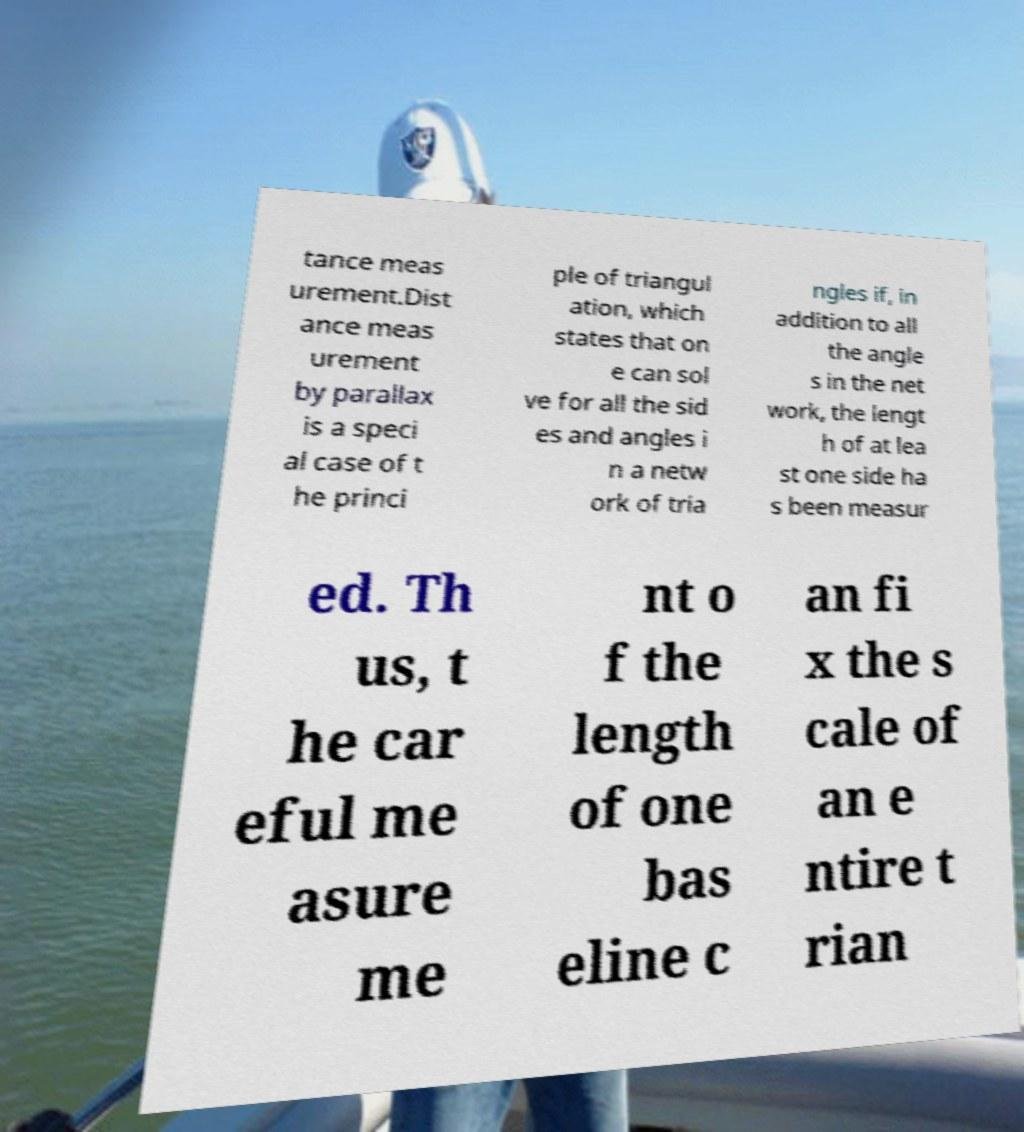For documentation purposes, I need the text within this image transcribed. Could you provide that? tance meas urement.Dist ance meas urement by parallax is a speci al case of t he princi ple of triangul ation, which states that on e can sol ve for all the sid es and angles i n a netw ork of tria ngles if, in addition to all the angle s in the net work, the lengt h of at lea st one side ha s been measur ed. Th us, t he car eful me asure me nt o f the length of one bas eline c an fi x the s cale of an e ntire t rian 